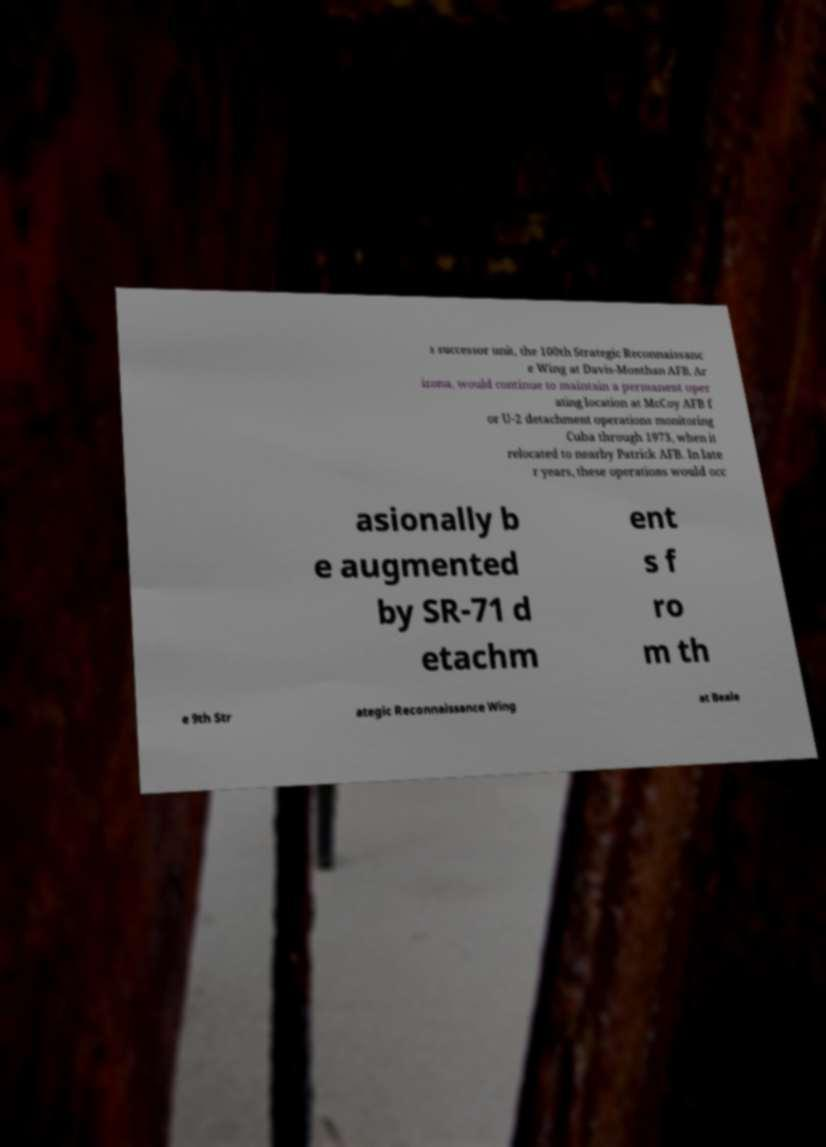Please identify and transcribe the text found in this image. s successor unit, the 100th Strategic Reconnaissanc e Wing at Davis-Monthan AFB, Ar izona, would continue to maintain a permanent oper ating location at McCoy AFB f or U-2 detachment operations monitoring Cuba through 1973, when it relocated to nearby Patrick AFB. In late r years, these operations would occ asionally b e augmented by SR-71 d etachm ent s f ro m th e 9th Str ategic Reconnaissance Wing at Beale 